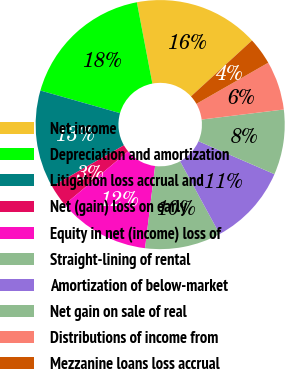<chart> <loc_0><loc_0><loc_500><loc_500><pie_chart><fcel>Net income<fcel>Depreciation and amortization<fcel>Litigation loss accrual and<fcel>Net (gain) loss on early<fcel>Equity in net (income) loss of<fcel>Straight-lining of rental<fcel>Amortization of below-market<fcel>Net gain on sale of real<fcel>Distributions of income from<fcel>Mezzanine loans loss accrual<nl><fcel>16.19%<fcel>17.59%<fcel>12.67%<fcel>2.83%<fcel>11.97%<fcel>9.86%<fcel>10.56%<fcel>8.45%<fcel>6.34%<fcel>3.53%<nl></chart> 